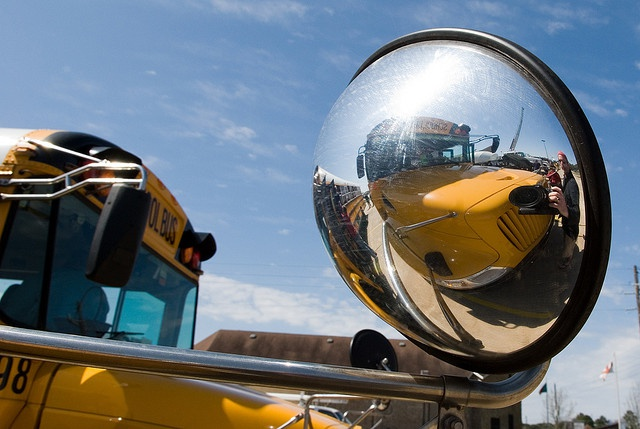Describe the objects in this image and their specific colors. I can see truck in darkgray, black, maroon, lightgray, and gray tones, bus in darkgray, black, maroon, and olive tones, and people in darkgray, black, gray, and maroon tones in this image. 